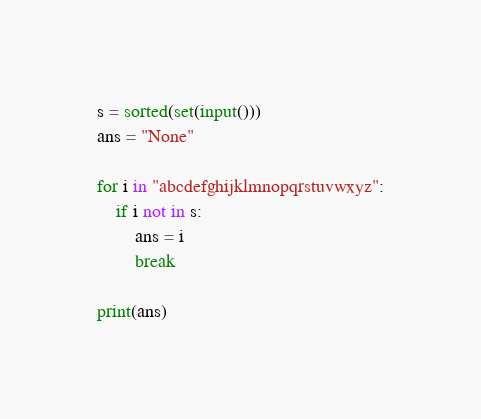Convert code to text. <code><loc_0><loc_0><loc_500><loc_500><_Python_>s = sorted(set(input()))
ans = "None"

for i in "abcdefghijklmnopqrstuvwxyz":
    if i not in s:
        ans = i
        break
        
print(ans)</code> 